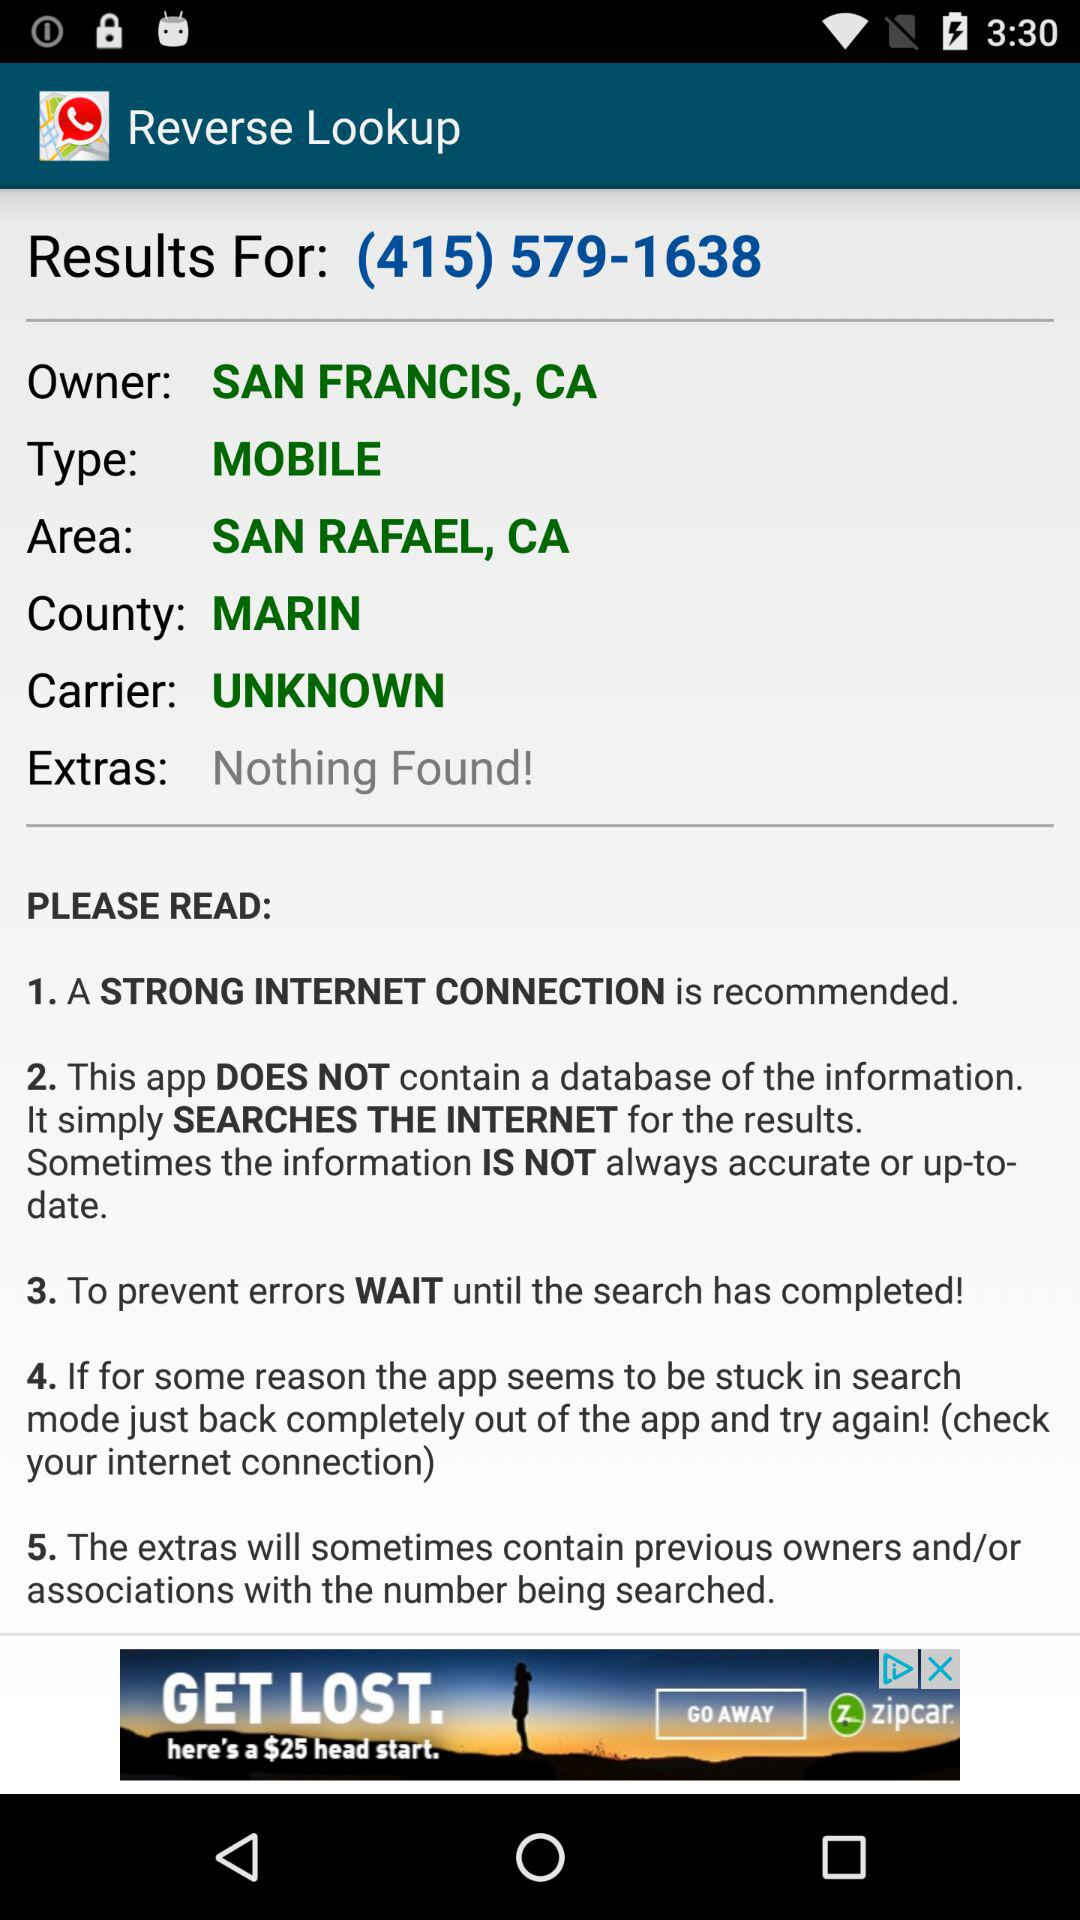What is the app name? The app name is "Reverse Lookup". 